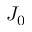Convert formula to latex. <formula><loc_0><loc_0><loc_500><loc_500>J _ { 0 }</formula> 